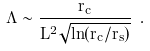Convert formula to latex. <formula><loc_0><loc_0><loc_500><loc_500>\Lambda \sim \frac { r _ { c } } { L ^ { 2 } \sqrt { \ln ( r _ { c } / r _ { s } ) } } \ .</formula> 